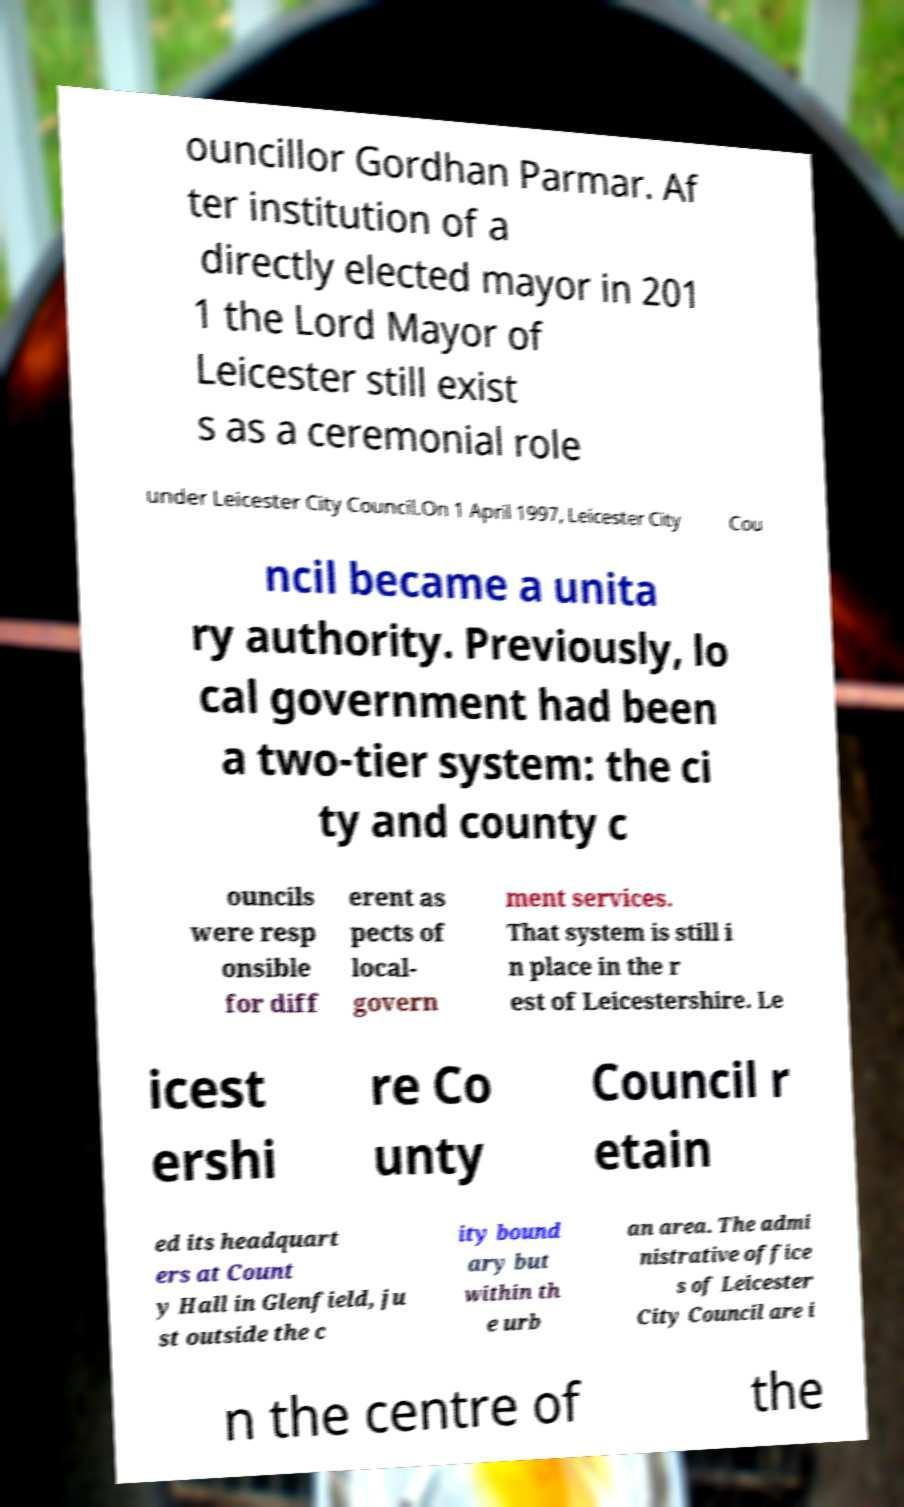Can you accurately transcribe the text from the provided image for me? ouncillor Gordhan Parmar. Af ter institution of a directly elected mayor in 201 1 the Lord Mayor of Leicester still exist s as a ceremonial role under Leicester City Council.On 1 April 1997, Leicester City Cou ncil became a unita ry authority. Previously, lo cal government had been a two-tier system: the ci ty and county c ouncils were resp onsible for diff erent as pects of local- govern ment services. That system is still i n place in the r est of Leicestershire. Le icest ershi re Co unty Council r etain ed its headquart ers at Count y Hall in Glenfield, ju st outside the c ity bound ary but within th e urb an area. The admi nistrative office s of Leicester City Council are i n the centre of the 